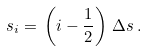Convert formula to latex. <formula><loc_0><loc_0><loc_500><loc_500>s _ { i } = \, \left ( i - \frac { 1 } { 2 } \right ) \, \Delta s \, .</formula> 